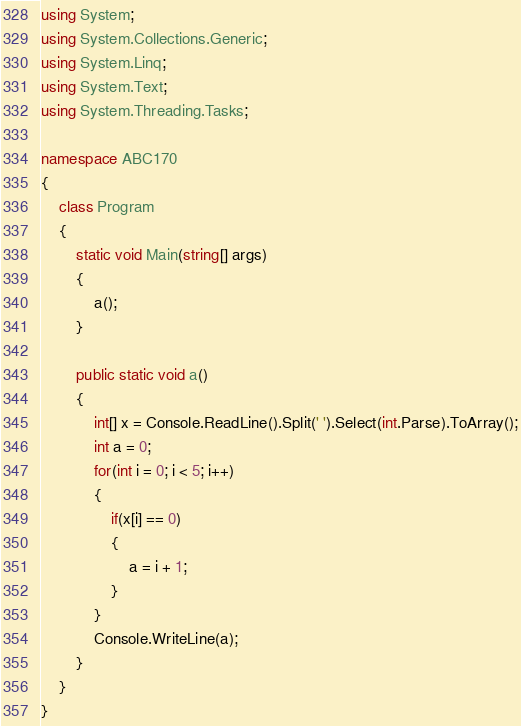<code> <loc_0><loc_0><loc_500><loc_500><_C#_>using System;
using System.Collections.Generic;
using System.Linq;
using System.Text;
using System.Threading.Tasks;

namespace ABC170
{
    class Program
    {
        static void Main(string[] args)
        {
            a();
        }

        public static void a()
        {
            int[] x = Console.ReadLine().Split(' ').Select(int.Parse).ToArray();
            int a = 0;
            for(int i = 0; i < 5; i++)
            {
                if(x[i] == 0)
                {
                    a = i + 1;
                }
            }
            Console.WriteLine(a);
        }
    }
}
</code> 